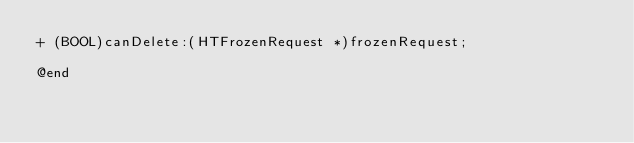Convert code to text. <code><loc_0><loc_0><loc_500><loc_500><_C_>+ (BOOL)canDelete:(HTFrozenRequest *)frozenRequest;

@end
</code> 